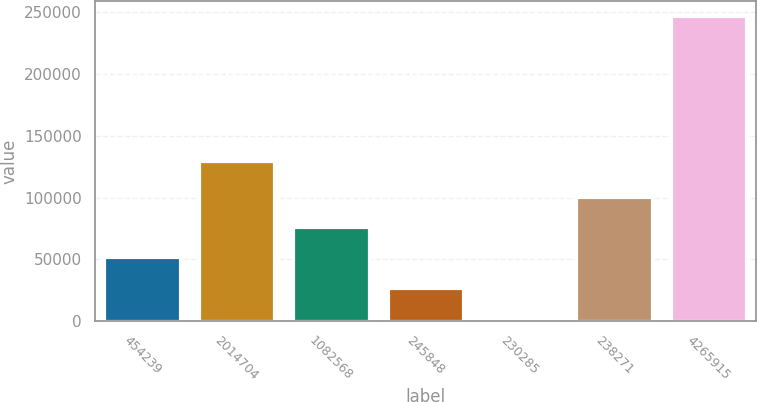<chart> <loc_0><loc_0><loc_500><loc_500><bar_chart><fcel>454239<fcel>2014704<fcel>1082568<fcel>245848<fcel>230285<fcel>238271<fcel>4265915<nl><fcel>51608.8<fcel>129940<fcel>76040.2<fcel>27177.4<fcel>2746<fcel>100472<fcel>247060<nl></chart> 